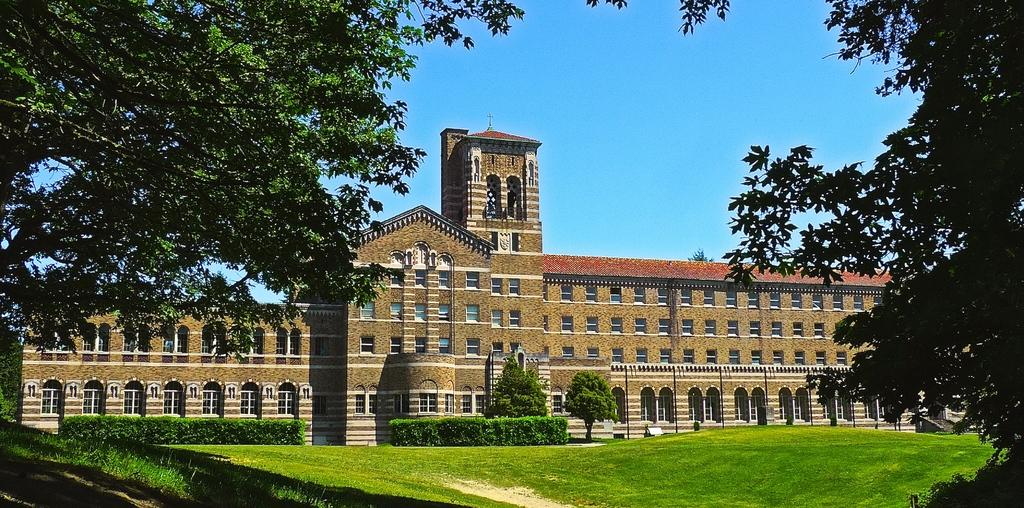What type of vegetation can be seen in the image? There are trees in the image. What type of structures are visible in the image? There are buildings in the image. What type of landscaping feature is present in the image? Hedges are present in the image. What is visible at the bottom of the image? There is ground visible at the bottom of the image. How much sugar is present in the image? There is no sugar present in the image. What type of pen can be seen in the image? There is no pen present in the image. 